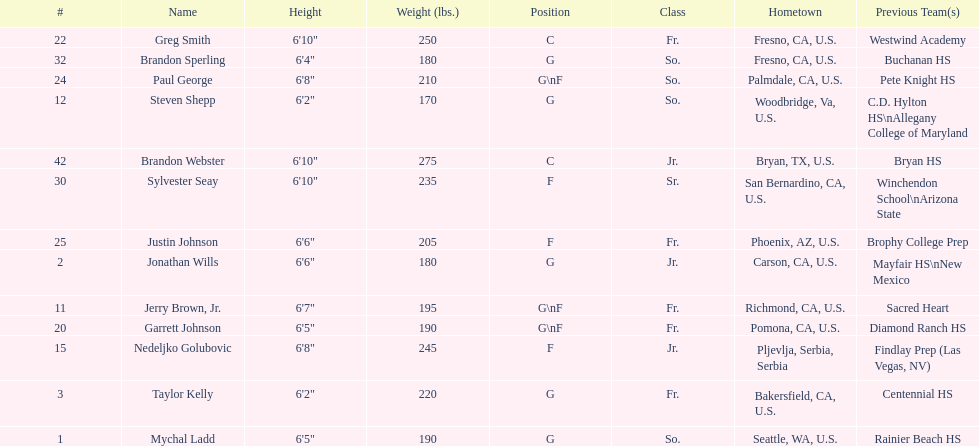Which player earlier performed for sacred heart? Jerry Brown, Jr. 